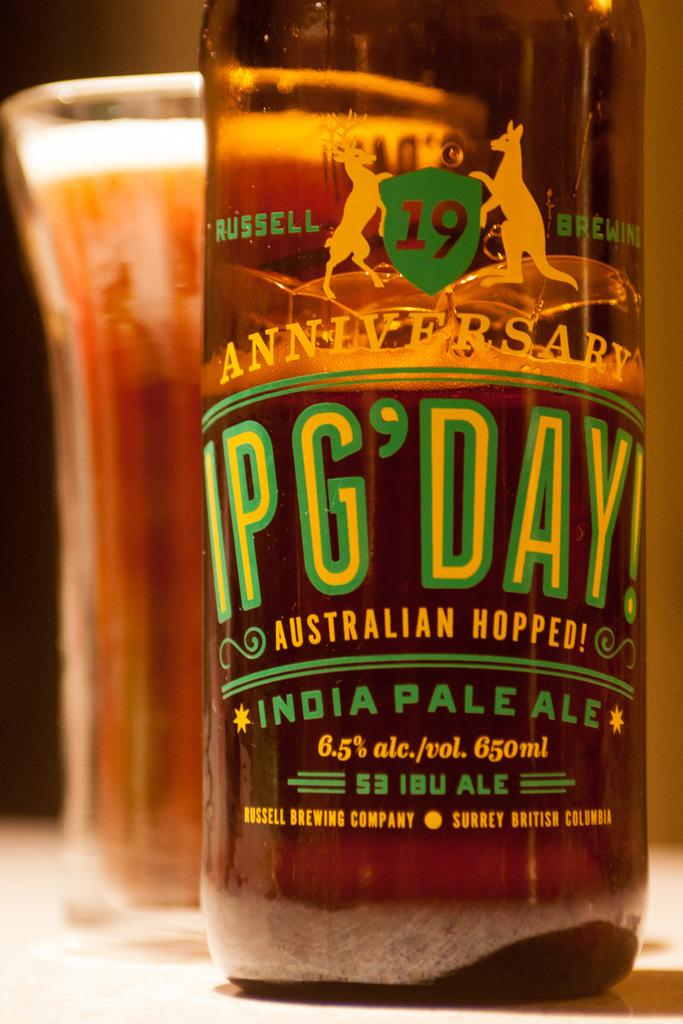<image>
Summarize the visual content of the image. A bottle of an Australian hopped India Pale Ale sits on a table. 